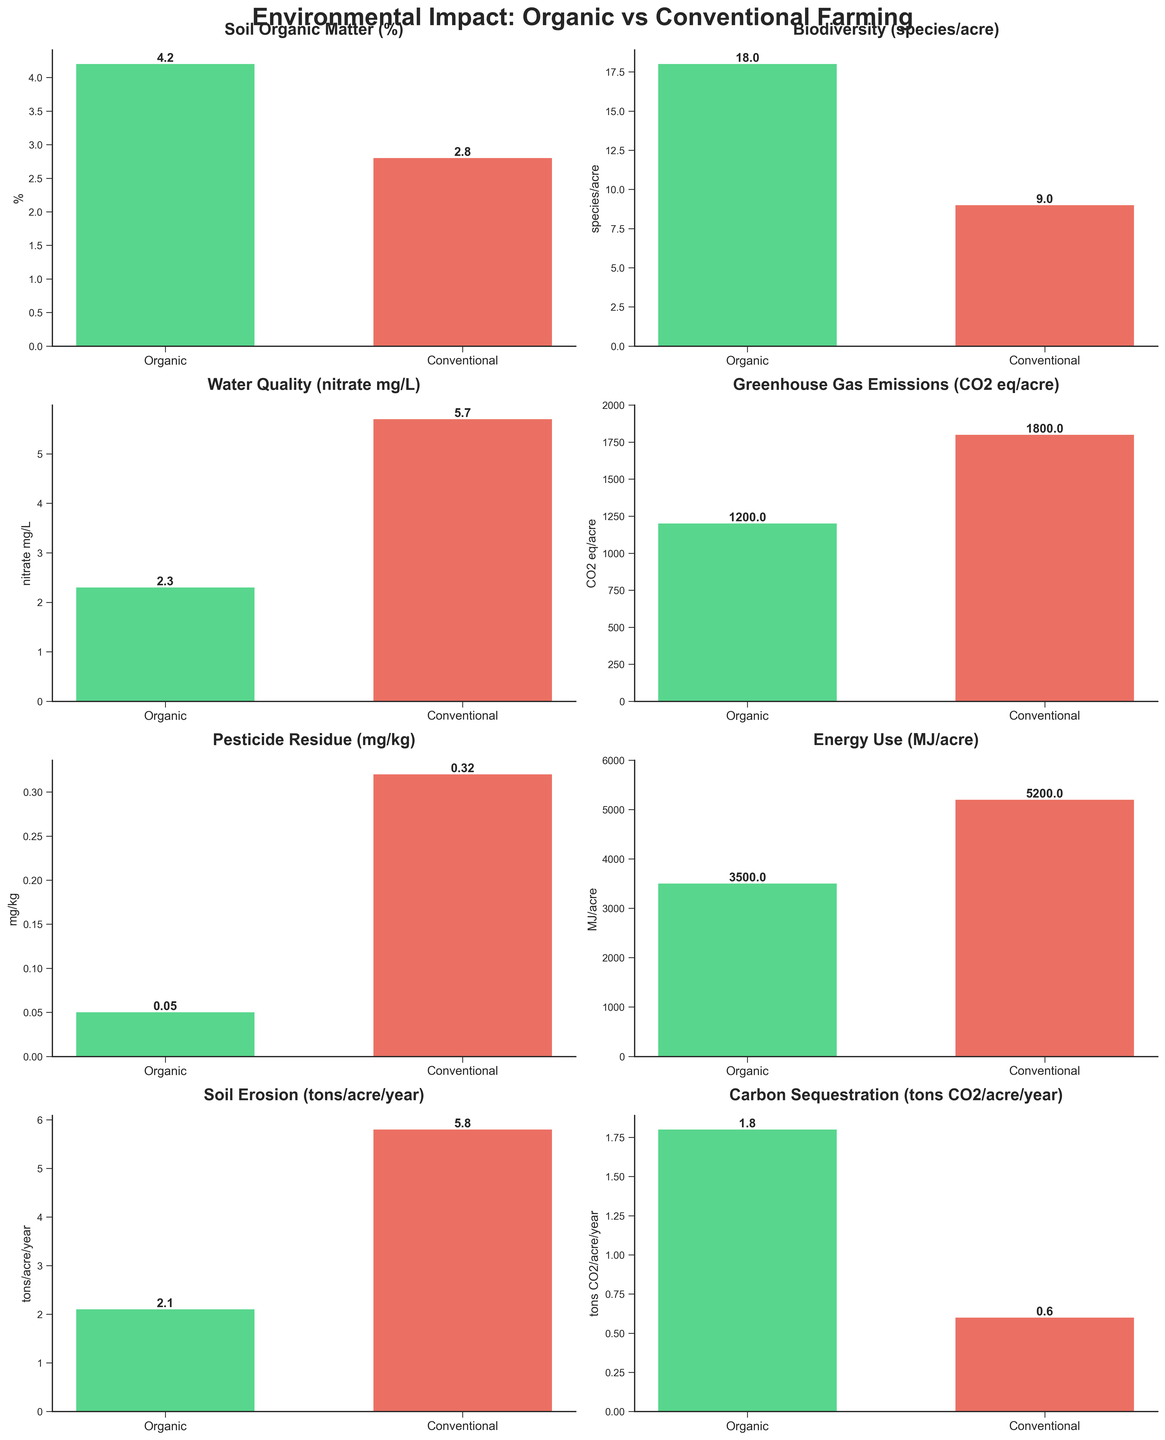What is the title of the figure? The title is written at the top of the figure and states the main topic of the plot.
Answer: Environmental Impact: Organic vs Conventional Farming Which farming type has the higher Soil Organic Matter percentage? By comparing the heights of the bars under the "Soil Organic Matter (%)" subplot, we see the bar for "Organic" is higher than the one for "Conventional."
Answer: Organic How many species per acre are supported by conventional farming? Look at the bar heights in the "Biodiversity (species/acre)" subplot and read the value from the label on the conventional bar.
Answer: 9 What is the difference in Greenhouse Gas Emissions between the two farming methods? Subtract the "Organic" value from the "Conventional" value in the "Greenhouse Gas Emissions (CO2 eq/acre)" subplot: 1800 - 1200.
Answer: 600 Which farming method results in lower water quality, and by how much? Check the "Water Quality (nitrate mg/L)" subplot. The conventional bar is higher than the organic bar. The difference is calculated by 5.7 - 2.3.
Answer: Conventional, by 3.4 mg/L What is the energy use difference in MJ/acre between organic and conventional methods? In the "Energy Use (MJ/acre)" subplot, subtract the "Organic" value from the "Conventional" value: 5200 - 3500.
Answer: 1700 MJ/acre In which indicator does organic farming have the smallest numerical advantage over conventional farming? Compare each subplot and identify the smallest difference. The smallest numerical difference is in the "Carbon Sequestration (tons CO2/acre/year)" subplot, calculated as 1.8 - 0.6 = 1.2.
Answer: Carbon Sequestration What are the pesticide residue levels for both organic and conventional methods? Look at the heights of the bars under the "Pesticide Residue (mg/kg)" subplot and read the values from the labels on both bars.
Answer: Organic: 0.05 mg/kg, Conventional: 0.32 mg/kg Which farming method is better for soil erosion control, and what is the difference in tons per acre per year? Check the "Soil Erosion (tons/acre/year)" subplot. The organic bar is lower than the conventional bar. The difference is calculated by 5.8 - 2.1.
Answer: Organic, by 3.7 tons/acre/year 